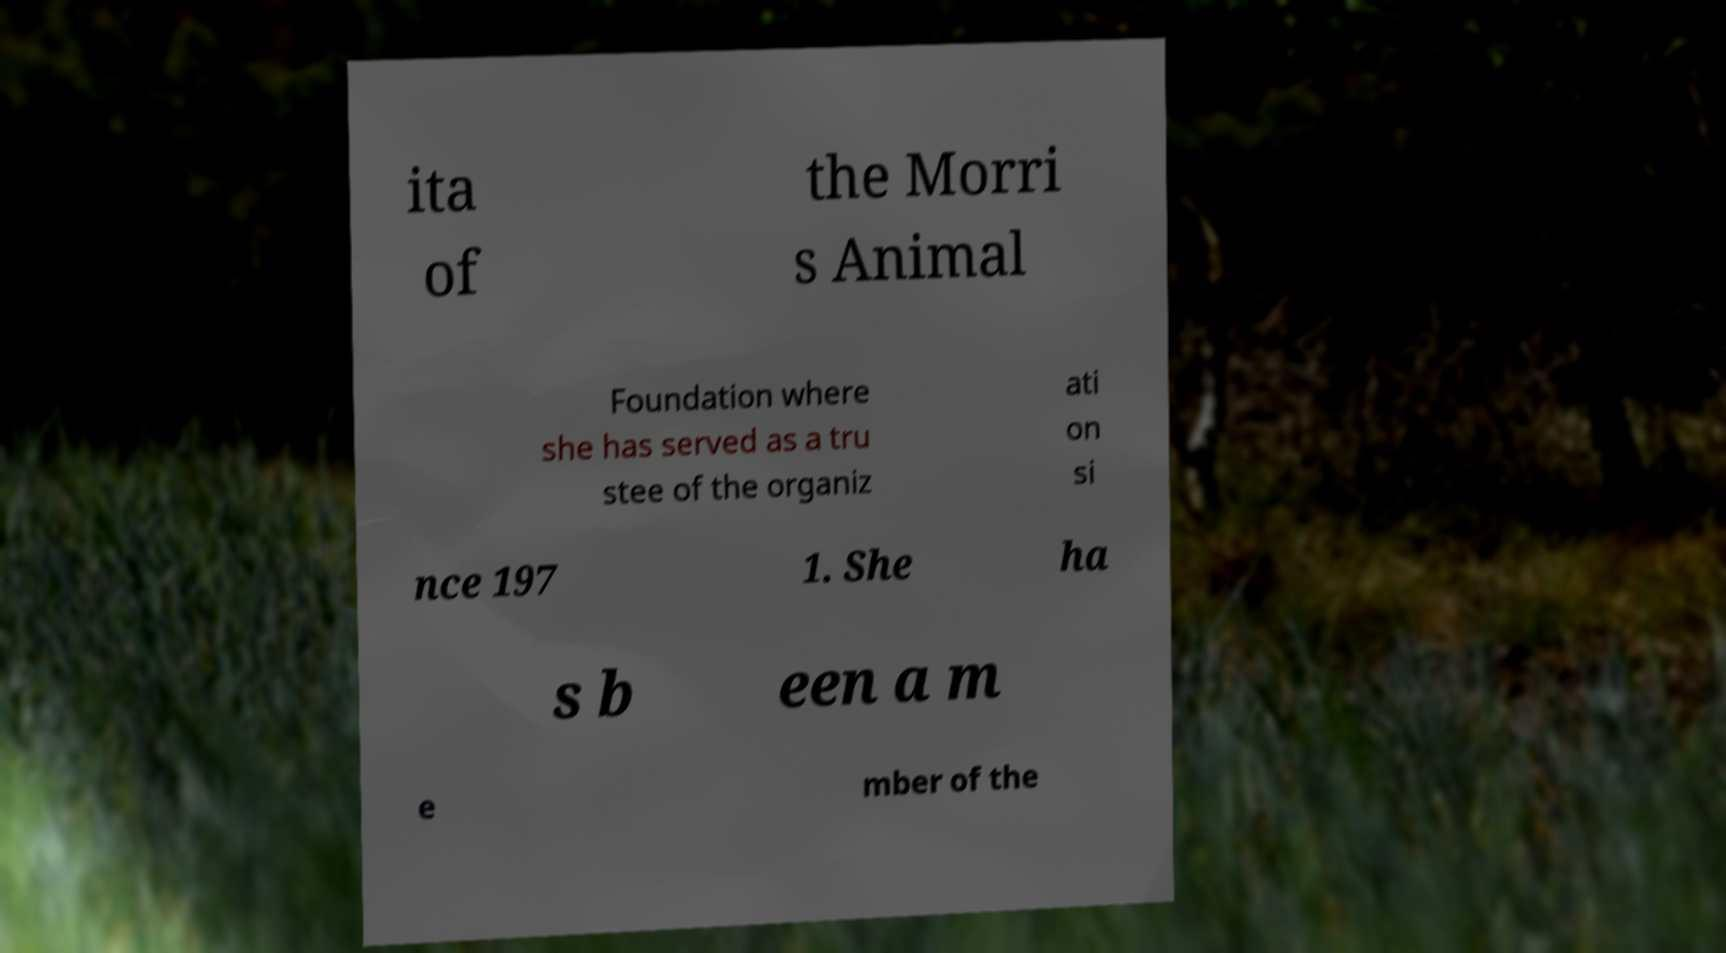There's text embedded in this image that I need extracted. Can you transcribe it verbatim? ita of the Morri s Animal Foundation where she has served as a tru stee of the organiz ati on si nce 197 1. She ha s b een a m e mber of the 